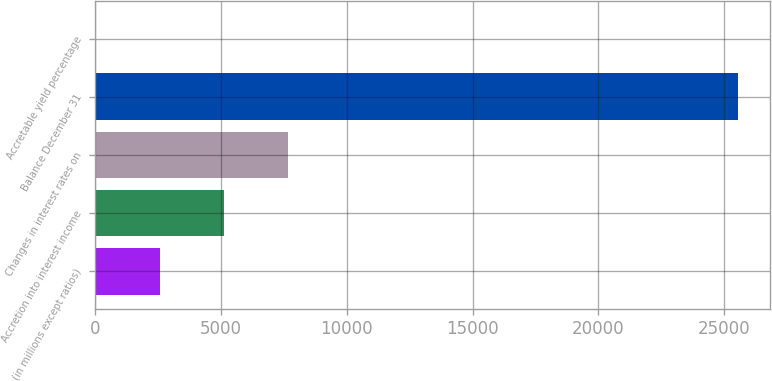Convert chart. <chart><loc_0><loc_0><loc_500><loc_500><bar_chart><fcel>(in millions except ratios)<fcel>Accretion into interest income<fcel>Changes in interest rates on<fcel>Balance December 31<fcel>Accretable yield percentage<nl><fcel>2559.03<fcel>5112.92<fcel>7666.81<fcel>25544<fcel>5.14<nl></chart> 